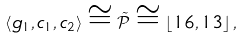Convert formula to latex. <formula><loc_0><loc_0><loc_500><loc_500>\left \langle g _ { 1 } , c _ { 1 } , c _ { 2 } \right \rangle \cong \tilde { \mathcal { P } } \cong \left \lfloor 1 6 , 1 3 \right \rfloor ,</formula> 